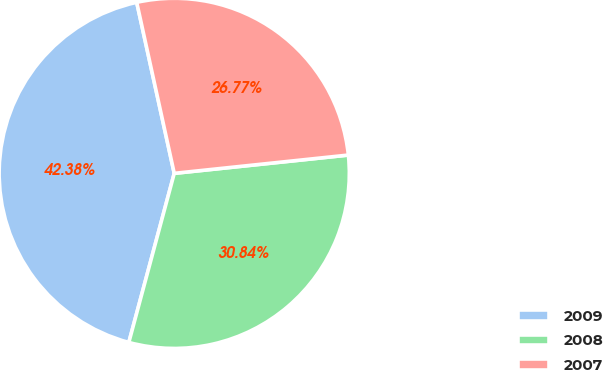Convert chart to OTSL. <chart><loc_0><loc_0><loc_500><loc_500><pie_chart><fcel>2009<fcel>2008<fcel>2007<nl><fcel>42.38%<fcel>30.84%<fcel>26.77%<nl></chart> 